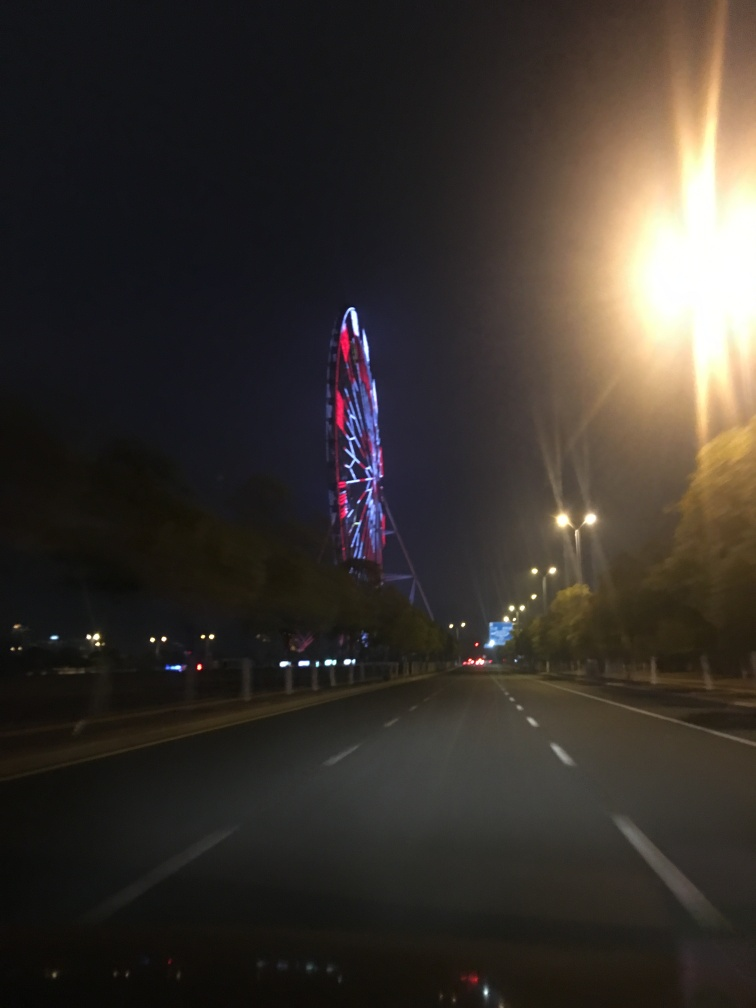What time of day does this image appear to have been taken? The image seems to have been taken during nighttime, as evidenced by the darkness of the sky and the illumination of the Ferris wheel and streetlights. 